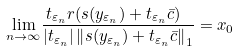Convert formula to latex. <formula><loc_0><loc_0><loc_500><loc_500>\underset { n \rightarrow \infty } { \lim } \frac { t _ { \varepsilon _ { n } } r ( s ( y _ { \varepsilon _ { n } } ) + t _ { \varepsilon _ { n } } \bar { c } ) \ } { \left | t _ { \varepsilon _ { n } } \right | \left \| s ( y _ { \varepsilon _ { n } } ) + t _ { \varepsilon _ { n } } \bar { c } \right \| _ { 1 } } = x _ { 0 }</formula> 